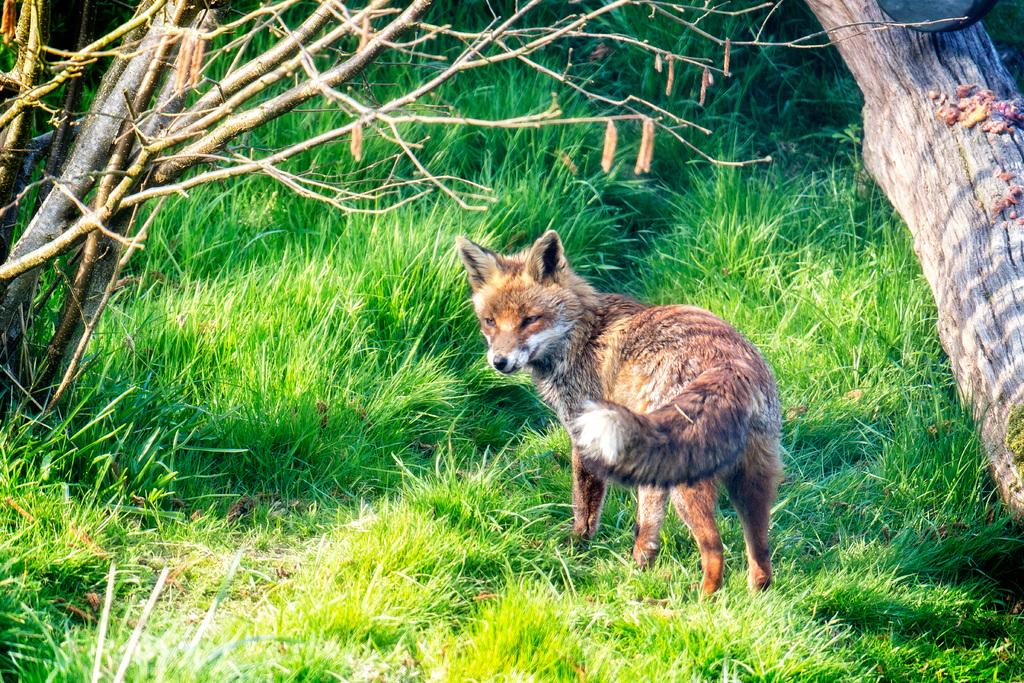What is the animal on the grass in the image? The animal on the grass in the image is not specified. What can be seen on the left side of the image? There are trees on the left side of the image. What can be seen on the right side of the image? There is a tree on the right side of the image. What type of vegetation is visible in the background of the image? There are plants in the background of the image. What type of ground cover is present in the background of the image? There is grass on the ground in the background of the image. What type of channel is visible in the image? There is no channel present in the image. What type of vessel is the animal using to navigate the grass in the image? There is no vessel present in the image, and the animal is not navigating the grass. 